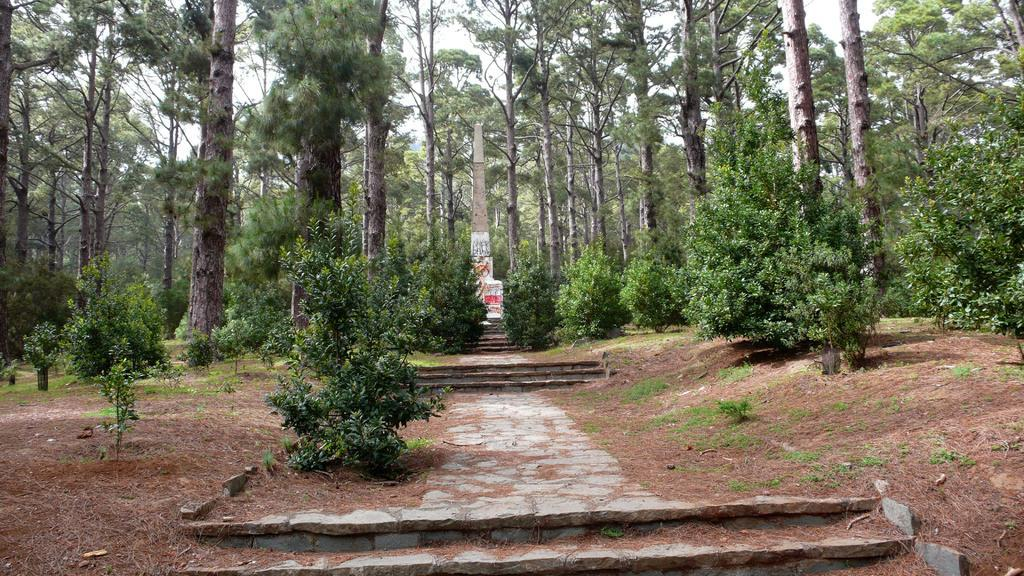What can be seen in the image that people might walk on? There is a path in the image that people might walk on. What can be seen in the image that people might use to go up or down? There are steps in the image that people might use to go up or down. What type of natural elements can be seen in the background of the image? There are plants and trees in the background of the image. What is the aftermath of the observation in the image? There is no observation or aftermath mentioned in the image; it simply shows a path, steps, plants, and trees. What is the reason for the presence of the trees in the image? The image does not provide a reason for the presence of the trees; they are simply part of the natural environment depicted in the background. 